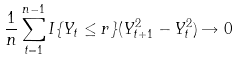Convert formula to latex. <formula><loc_0><loc_0><loc_500><loc_500>\frac { 1 } { n } \sum _ { t = 1 } ^ { n - 1 } I \{ Y _ { t } \leq r \} ( Y ^ { 2 } _ { t + 1 } - Y ^ { 2 } _ { t } ) \rightarrow 0</formula> 